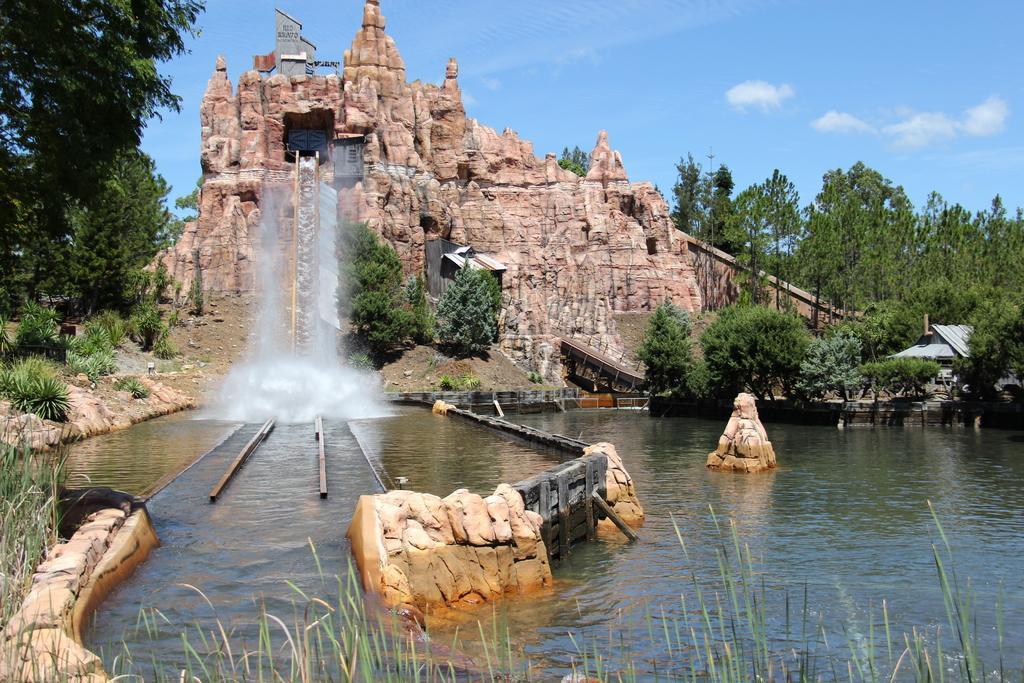How would you summarize this image in a sentence or two? This image is clicked outside. There is water in the middle. There are trees on the left side and right side. There is something like waterfalls in the middle. There is sky at the top. 